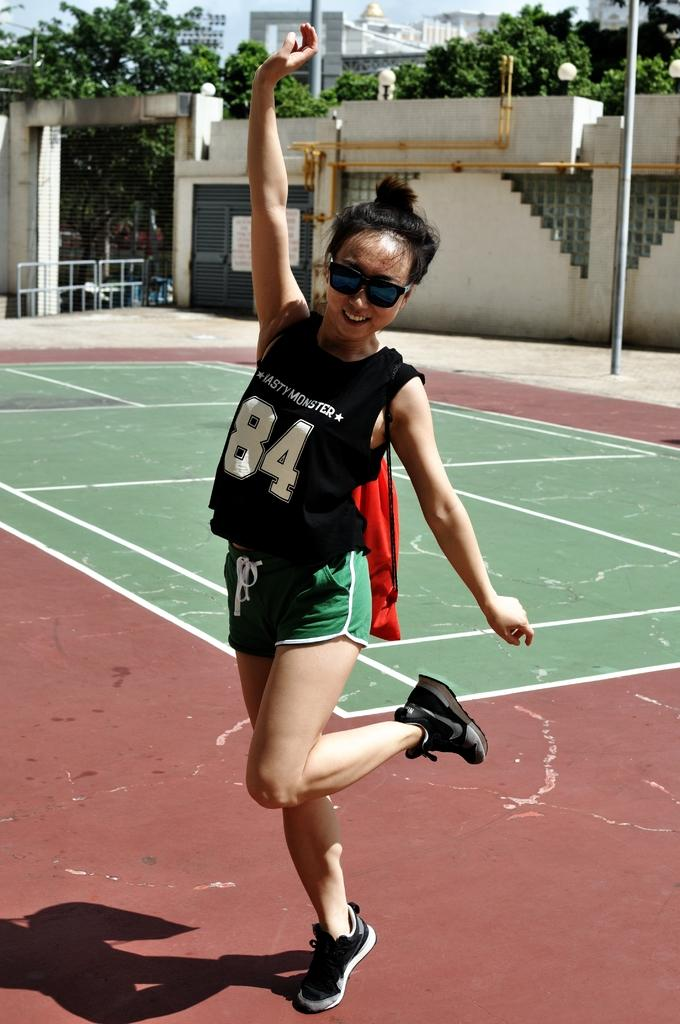<image>
Provide a brief description of the given image. A young girl with a team jersey on that says Nasty Monster. 